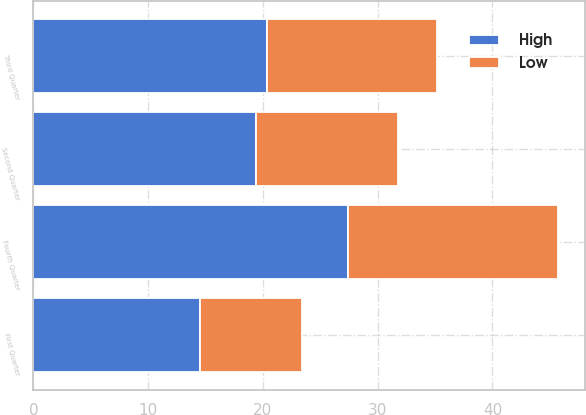Convert chart. <chart><loc_0><loc_0><loc_500><loc_500><stacked_bar_chart><ecel><fcel>First Quarter<fcel>Second Quarter<fcel>Third Quarter<fcel>Fourth Quarter<nl><fcel>High<fcel>14.5<fcel>19.42<fcel>20.36<fcel>27.4<nl><fcel>Low<fcel>8.89<fcel>12.31<fcel>14.77<fcel>18.34<nl></chart> 